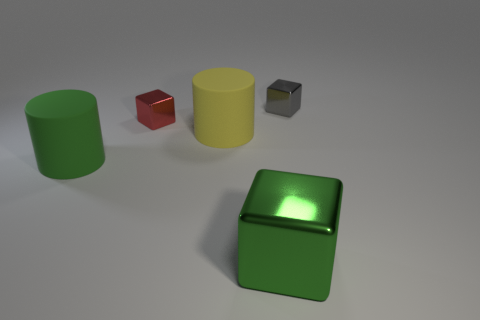Are there the same number of green metal blocks that are on the right side of the green metal cube and tiny shiny objects that are right of the gray block?
Your response must be concise. Yes. The object that is in front of the large yellow cylinder and on the right side of the tiny red thing is made of what material?
Offer a very short reply. Metal. Does the red cube have the same size as the yellow matte cylinder that is on the left side of the big metallic thing?
Provide a short and direct response. No. Is the number of red metallic blocks on the left side of the large metallic object greater than the number of small green rubber objects?
Offer a terse response. Yes. There is a big metallic block in front of the cube on the right side of the shiny thing that is in front of the big green rubber cylinder; what color is it?
Your answer should be compact. Green. Are the yellow thing and the red block made of the same material?
Offer a terse response. No. Is there a red shiny block of the same size as the green matte cylinder?
Offer a very short reply. No. There is a green block that is the same size as the green matte cylinder; what is it made of?
Offer a terse response. Metal. Is there a big green metal object of the same shape as the green matte object?
Make the answer very short. No. There is a big object that is the same color as the big cube; what material is it?
Offer a very short reply. Rubber. 